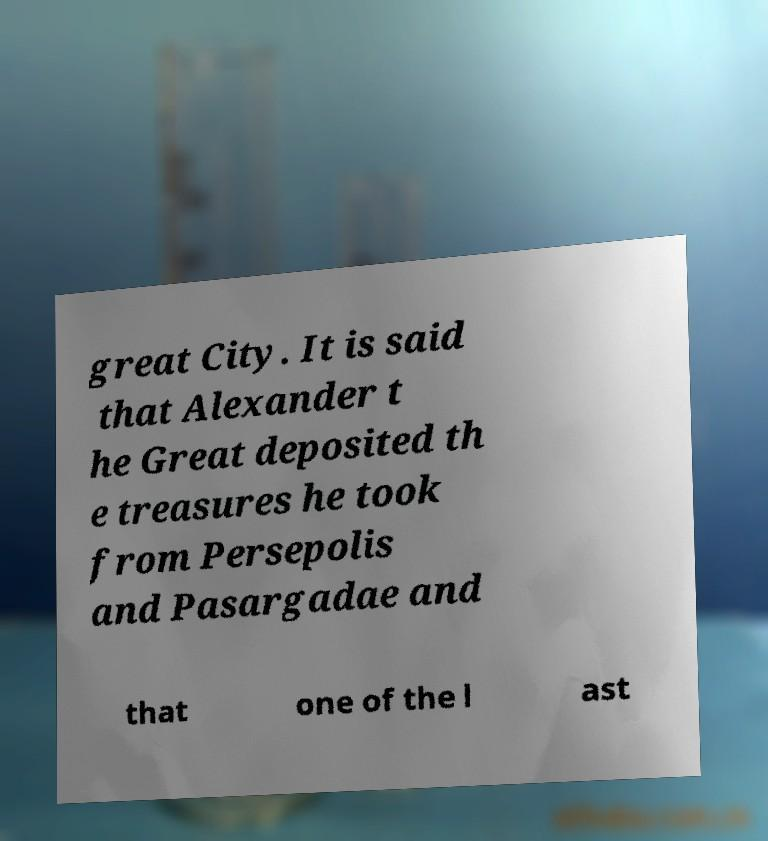Could you assist in decoding the text presented in this image and type it out clearly? great City. It is said that Alexander t he Great deposited th e treasures he took from Persepolis and Pasargadae and that one of the l ast 